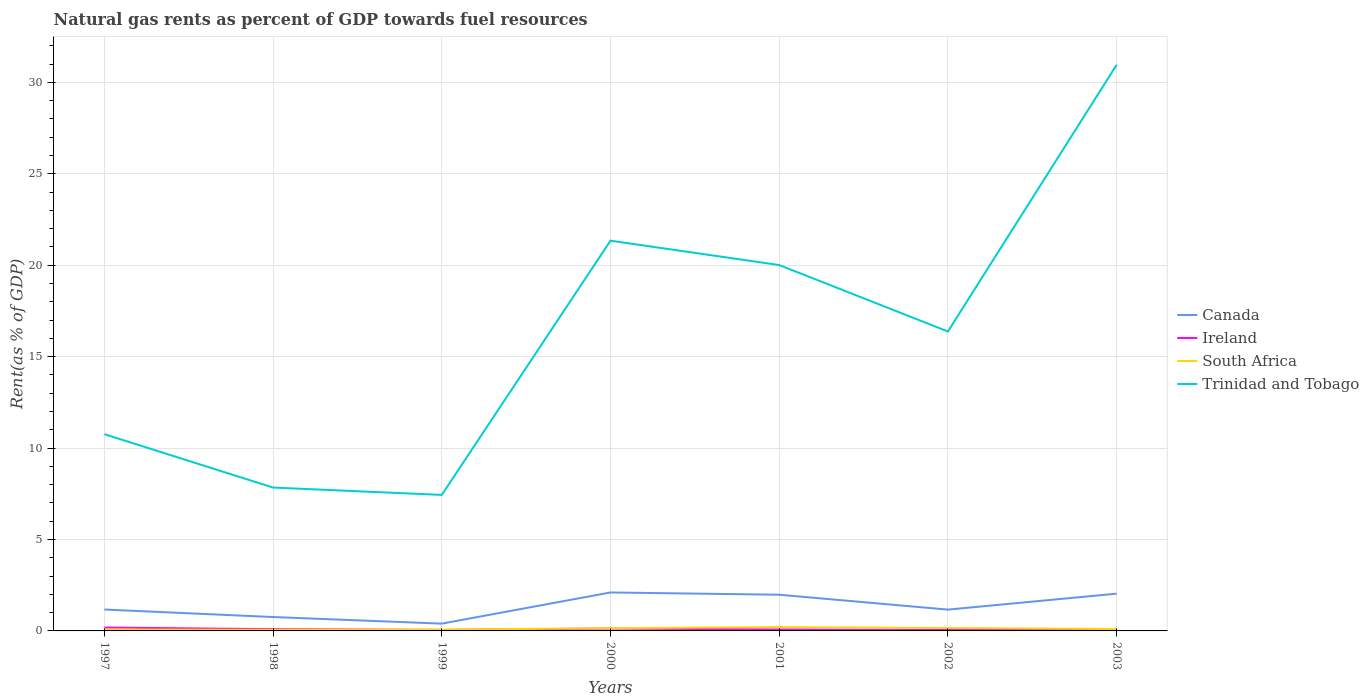Across all years, what is the maximum matural gas rent in Canada?
Offer a terse response. 0.4. In which year was the matural gas rent in Canada maximum?
Your answer should be very brief. 1999. What is the total matural gas rent in Trinidad and Tobago in the graph?
Ensure brevity in your answer.  -12.57. What is the difference between the highest and the second highest matural gas rent in Trinidad and Tobago?
Your answer should be very brief. 23.52. Is the matural gas rent in South Africa strictly greater than the matural gas rent in Ireland over the years?
Provide a succinct answer. No. How many years are there in the graph?
Provide a succinct answer. 7. Does the graph contain grids?
Offer a very short reply. Yes. How are the legend labels stacked?
Offer a terse response. Vertical. What is the title of the graph?
Your answer should be compact. Natural gas rents as percent of GDP towards fuel resources. Does "Kenya" appear as one of the legend labels in the graph?
Give a very brief answer. No. What is the label or title of the Y-axis?
Keep it short and to the point. Rent(as % of GDP). What is the Rent(as % of GDP) of Canada in 1997?
Your answer should be very brief. 1.17. What is the Rent(as % of GDP) in Ireland in 1997?
Provide a succinct answer. 0.18. What is the Rent(as % of GDP) of South Africa in 1997?
Provide a short and direct response. 0.08. What is the Rent(as % of GDP) in Trinidad and Tobago in 1997?
Keep it short and to the point. 10.76. What is the Rent(as % of GDP) in Canada in 1998?
Give a very brief answer. 0.76. What is the Rent(as % of GDP) in Ireland in 1998?
Provide a succinct answer. 0.1. What is the Rent(as % of GDP) of South Africa in 1998?
Give a very brief answer. 0.06. What is the Rent(as % of GDP) of Trinidad and Tobago in 1998?
Offer a very short reply. 7.84. What is the Rent(as % of GDP) of Canada in 1999?
Keep it short and to the point. 0.4. What is the Rent(as % of GDP) in Ireland in 1999?
Ensure brevity in your answer.  0.06. What is the Rent(as % of GDP) of South Africa in 1999?
Provide a succinct answer. 0.07. What is the Rent(as % of GDP) in Trinidad and Tobago in 1999?
Your answer should be very brief. 7.44. What is the Rent(as % of GDP) in Canada in 2000?
Provide a short and direct response. 2.1. What is the Rent(as % of GDP) of Ireland in 2000?
Your answer should be compact. 0.13. What is the Rent(as % of GDP) in South Africa in 2000?
Offer a terse response. 0.15. What is the Rent(as % of GDP) of Trinidad and Tobago in 2000?
Give a very brief answer. 21.34. What is the Rent(as % of GDP) of Canada in 2001?
Offer a terse response. 1.98. What is the Rent(as % of GDP) in Ireland in 2001?
Give a very brief answer. 0.08. What is the Rent(as % of GDP) in South Africa in 2001?
Keep it short and to the point. 0.21. What is the Rent(as % of GDP) in Trinidad and Tobago in 2001?
Make the answer very short. 20.01. What is the Rent(as % of GDP) in Canada in 2002?
Give a very brief answer. 1.17. What is the Rent(as % of GDP) of Ireland in 2002?
Your answer should be very brief. 0.05. What is the Rent(as % of GDP) in South Africa in 2002?
Keep it short and to the point. 0.16. What is the Rent(as % of GDP) of Trinidad and Tobago in 2002?
Your answer should be very brief. 16.37. What is the Rent(as % of GDP) of Canada in 2003?
Make the answer very short. 2.04. What is the Rent(as % of GDP) of Ireland in 2003?
Offer a very short reply. 0.05. What is the Rent(as % of GDP) of South Africa in 2003?
Your response must be concise. 0.1. What is the Rent(as % of GDP) in Trinidad and Tobago in 2003?
Give a very brief answer. 30.96. Across all years, what is the maximum Rent(as % of GDP) in Canada?
Give a very brief answer. 2.1. Across all years, what is the maximum Rent(as % of GDP) of Ireland?
Your response must be concise. 0.18. Across all years, what is the maximum Rent(as % of GDP) of South Africa?
Offer a very short reply. 0.21. Across all years, what is the maximum Rent(as % of GDP) of Trinidad and Tobago?
Give a very brief answer. 30.96. Across all years, what is the minimum Rent(as % of GDP) of Canada?
Make the answer very short. 0.4. Across all years, what is the minimum Rent(as % of GDP) in Ireland?
Provide a short and direct response. 0.05. Across all years, what is the minimum Rent(as % of GDP) in South Africa?
Keep it short and to the point. 0.06. Across all years, what is the minimum Rent(as % of GDP) of Trinidad and Tobago?
Provide a short and direct response. 7.44. What is the total Rent(as % of GDP) of Canada in the graph?
Your answer should be compact. 9.61. What is the total Rent(as % of GDP) of Ireland in the graph?
Give a very brief answer. 0.65. What is the total Rent(as % of GDP) in South Africa in the graph?
Offer a terse response. 0.83. What is the total Rent(as % of GDP) in Trinidad and Tobago in the graph?
Provide a succinct answer. 114.71. What is the difference between the Rent(as % of GDP) in Canada in 1997 and that in 1998?
Your answer should be very brief. 0.41. What is the difference between the Rent(as % of GDP) in Ireland in 1997 and that in 1998?
Make the answer very short. 0.09. What is the difference between the Rent(as % of GDP) in South Africa in 1997 and that in 1998?
Provide a short and direct response. 0.02. What is the difference between the Rent(as % of GDP) of Trinidad and Tobago in 1997 and that in 1998?
Ensure brevity in your answer.  2.92. What is the difference between the Rent(as % of GDP) in Canada in 1997 and that in 1999?
Make the answer very short. 0.77. What is the difference between the Rent(as % of GDP) in Ireland in 1997 and that in 1999?
Provide a short and direct response. 0.13. What is the difference between the Rent(as % of GDP) in South Africa in 1997 and that in 1999?
Provide a succinct answer. 0.01. What is the difference between the Rent(as % of GDP) of Trinidad and Tobago in 1997 and that in 1999?
Ensure brevity in your answer.  3.32. What is the difference between the Rent(as % of GDP) of Canada in 1997 and that in 2000?
Provide a succinct answer. -0.93. What is the difference between the Rent(as % of GDP) in Ireland in 1997 and that in 2000?
Make the answer very short. 0.05. What is the difference between the Rent(as % of GDP) of South Africa in 1997 and that in 2000?
Ensure brevity in your answer.  -0.07. What is the difference between the Rent(as % of GDP) in Trinidad and Tobago in 1997 and that in 2000?
Your answer should be compact. -10.58. What is the difference between the Rent(as % of GDP) of Canada in 1997 and that in 2001?
Keep it short and to the point. -0.81. What is the difference between the Rent(as % of GDP) of Ireland in 1997 and that in 2001?
Your answer should be very brief. 0.11. What is the difference between the Rent(as % of GDP) in South Africa in 1997 and that in 2001?
Keep it short and to the point. -0.13. What is the difference between the Rent(as % of GDP) of Trinidad and Tobago in 1997 and that in 2001?
Ensure brevity in your answer.  -9.25. What is the difference between the Rent(as % of GDP) of Canada in 1997 and that in 2002?
Your answer should be compact. 0. What is the difference between the Rent(as % of GDP) in Ireland in 1997 and that in 2002?
Make the answer very short. 0.14. What is the difference between the Rent(as % of GDP) in South Africa in 1997 and that in 2002?
Keep it short and to the point. -0.08. What is the difference between the Rent(as % of GDP) in Trinidad and Tobago in 1997 and that in 2002?
Keep it short and to the point. -5.61. What is the difference between the Rent(as % of GDP) of Canada in 1997 and that in 2003?
Keep it short and to the point. -0.87. What is the difference between the Rent(as % of GDP) in Ireland in 1997 and that in 2003?
Keep it short and to the point. 0.13. What is the difference between the Rent(as % of GDP) in South Africa in 1997 and that in 2003?
Provide a succinct answer. -0.02. What is the difference between the Rent(as % of GDP) of Trinidad and Tobago in 1997 and that in 2003?
Your answer should be compact. -20.2. What is the difference between the Rent(as % of GDP) in Canada in 1998 and that in 1999?
Provide a short and direct response. 0.36. What is the difference between the Rent(as % of GDP) in Ireland in 1998 and that in 1999?
Give a very brief answer. 0.04. What is the difference between the Rent(as % of GDP) in South Africa in 1998 and that in 1999?
Provide a succinct answer. -0.01. What is the difference between the Rent(as % of GDP) in Trinidad and Tobago in 1998 and that in 1999?
Your answer should be very brief. 0.4. What is the difference between the Rent(as % of GDP) in Canada in 1998 and that in 2000?
Offer a terse response. -1.34. What is the difference between the Rent(as % of GDP) in Ireland in 1998 and that in 2000?
Give a very brief answer. -0.04. What is the difference between the Rent(as % of GDP) of South Africa in 1998 and that in 2000?
Offer a very short reply. -0.09. What is the difference between the Rent(as % of GDP) of Trinidad and Tobago in 1998 and that in 2000?
Keep it short and to the point. -13.5. What is the difference between the Rent(as % of GDP) in Canada in 1998 and that in 2001?
Provide a short and direct response. -1.22. What is the difference between the Rent(as % of GDP) of Ireland in 1998 and that in 2001?
Offer a terse response. 0.02. What is the difference between the Rent(as % of GDP) in South Africa in 1998 and that in 2001?
Provide a succinct answer. -0.15. What is the difference between the Rent(as % of GDP) in Trinidad and Tobago in 1998 and that in 2001?
Keep it short and to the point. -12.17. What is the difference between the Rent(as % of GDP) in Canada in 1998 and that in 2002?
Your response must be concise. -0.41. What is the difference between the Rent(as % of GDP) in Ireland in 1998 and that in 2002?
Your response must be concise. 0.05. What is the difference between the Rent(as % of GDP) in South Africa in 1998 and that in 2002?
Provide a short and direct response. -0.1. What is the difference between the Rent(as % of GDP) in Trinidad and Tobago in 1998 and that in 2002?
Provide a succinct answer. -8.53. What is the difference between the Rent(as % of GDP) of Canada in 1998 and that in 2003?
Make the answer very short. -1.28. What is the difference between the Rent(as % of GDP) in Ireland in 1998 and that in 2003?
Provide a succinct answer. 0.04. What is the difference between the Rent(as % of GDP) of South Africa in 1998 and that in 2003?
Make the answer very short. -0.04. What is the difference between the Rent(as % of GDP) in Trinidad and Tobago in 1998 and that in 2003?
Offer a terse response. -23.12. What is the difference between the Rent(as % of GDP) of Canada in 1999 and that in 2000?
Offer a terse response. -1.7. What is the difference between the Rent(as % of GDP) in Ireland in 1999 and that in 2000?
Your answer should be compact. -0.07. What is the difference between the Rent(as % of GDP) in South Africa in 1999 and that in 2000?
Give a very brief answer. -0.08. What is the difference between the Rent(as % of GDP) in Trinidad and Tobago in 1999 and that in 2000?
Offer a very short reply. -13.9. What is the difference between the Rent(as % of GDP) in Canada in 1999 and that in 2001?
Your answer should be very brief. -1.58. What is the difference between the Rent(as % of GDP) of Ireland in 1999 and that in 2001?
Your answer should be very brief. -0.02. What is the difference between the Rent(as % of GDP) of South Africa in 1999 and that in 2001?
Keep it short and to the point. -0.14. What is the difference between the Rent(as % of GDP) in Trinidad and Tobago in 1999 and that in 2001?
Your response must be concise. -12.57. What is the difference between the Rent(as % of GDP) of Canada in 1999 and that in 2002?
Keep it short and to the point. -0.77. What is the difference between the Rent(as % of GDP) in Ireland in 1999 and that in 2002?
Make the answer very short. 0.01. What is the difference between the Rent(as % of GDP) in South Africa in 1999 and that in 2002?
Ensure brevity in your answer.  -0.09. What is the difference between the Rent(as % of GDP) of Trinidad and Tobago in 1999 and that in 2002?
Make the answer very short. -8.94. What is the difference between the Rent(as % of GDP) of Canada in 1999 and that in 2003?
Offer a terse response. -1.64. What is the difference between the Rent(as % of GDP) in Ireland in 1999 and that in 2003?
Give a very brief answer. 0. What is the difference between the Rent(as % of GDP) in South Africa in 1999 and that in 2003?
Your answer should be compact. -0.04. What is the difference between the Rent(as % of GDP) in Trinidad and Tobago in 1999 and that in 2003?
Provide a succinct answer. -23.52. What is the difference between the Rent(as % of GDP) in Canada in 2000 and that in 2001?
Provide a succinct answer. 0.12. What is the difference between the Rent(as % of GDP) of Ireland in 2000 and that in 2001?
Give a very brief answer. 0.05. What is the difference between the Rent(as % of GDP) in South Africa in 2000 and that in 2001?
Ensure brevity in your answer.  -0.06. What is the difference between the Rent(as % of GDP) of Trinidad and Tobago in 2000 and that in 2001?
Make the answer very short. 1.33. What is the difference between the Rent(as % of GDP) in Canada in 2000 and that in 2002?
Make the answer very short. 0.94. What is the difference between the Rent(as % of GDP) in Ireland in 2000 and that in 2002?
Your response must be concise. 0.08. What is the difference between the Rent(as % of GDP) of South Africa in 2000 and that in 2002?
Ensure brevity in your answer.  -0.01. What is the difference between the Rent(as % of GDP) of Trinidad and Tobago in 2000 and that in 2002?
Offer a very short reply. 4.96. What is the difference between the Rent(as % of GDP) of Canada in 2000 and that in 2003?
Make the answer very short. 0.07. What is the difference between the Rent(as % of GDP) in Ireland in 2000 and that in 2003?
Make the answer very short. 0.08. What is the difference between the Rent(as % of GDP) of South Africa in 2000 and that in 2003?
Offer a very short reply. 0.05. What is the difference between the Rent(as % of GDP) in Trinidad and Tobago in 2000 and that in 2003?
Offer a very short reply. -9.62. What is the difference between the Rent(as % of GDP) of Canada in 2001 and that in 2002?
Make the answer very short. 0.81. What is the difference between the Rent(as % of GDP) of Ireland in 2001 and that in 2002?
Ensure brevity in your answer.  0.03. What is the difference between the Rent(as % of GDP) in South Africa in 2001 and that in 2002?
Offer a terse response. 0.05. What is the difference between the Rent(as % of GDP) of Trinidad and Tobago in 2001 and that in 2002?
Provide a succinct answer. 3.63. What is the difference between the Rent(as % of GDP) in Canada in 2001 and that in 2003?
Your response must be concise. -0.06. What is the difference between the Rent(as % of GDP) in Ireland in 2001 and that in 2003?
Provide a succinct answer. 0.03. What is the difference between the Rent(as % of GDP) of South Africa in 2001 and that in 2003?
Offer a terse response. 0.11. What is the difference between the Rent(as % of GDP) of Trinidad and Tobago in 2001 and that in 2003?
Make the answer very short. -10.95. What is the difference between the Rent(as % of GDP) in Canada in 2002 and that in 2003?
Provide a short and direct response. -0.87. What is the difference between the Rent(as % of GDP) in Ireland in 2002 and that in 2003?
Your response must be concise. -0. What is the difference between the Rent(as % of GDP) of South Africa in 2002 and that in 2003?
Your answer should be very brief. 0.06. What is the difference between the Rent(as % of GDP) of Trinidad and Tobago in 2002 and that in 2003?
Give a very brief answer. -14.58. What is the difference between the Rent(as % of GDP) of Canada in 1997 and the Rent(as % of GDP) of Ireland in 1998?
Your response must be concise. 1.07. What is the difference between the Rent(as % of GDP) in Canada in 1997 and the Rent(as % of GDP) in South Africa in 1998?
Your response must be concise. 1.11. What is the difference between the Rent(as % of GDP) in Canada in 1997 and the Rent(as % of GDP) in Trinidad and Tobago in 1998?
Ensure brevity in your answer.  -6.67. What is the difference between the Rent(as % of GDP) in Ireland in 1997 and the Rent(as % of GDP) in South Africa in 1998?
Your response must be concise. 0.13. What is the difference between the Rent(as % of GDP) of Ireland in 1997 and the Rent(as % of GDP) of Trinidad and Tobago in 1998?
Your answer should be very brief. -7.66. What is the difference between the Rent(as % of GDP) in South Africa in 1997 and the Rent(as % of GDP) in Trinidad and Tobago in 1998?
Offer a very short reply. -7.76. What is the difference between the Rent(as % of GDP) of Canada in 1997 and the Rent(as % of GDP) of Ireland in 1999?
Give a very brief answer. 1.11. What is the difference between the Rent(as % of GDP) of Canada in 1997 and the Rent(as % of GDP) of South Africa in 1999?
Your response must be concise. 1.1. What is the difference between the Rent(as % of GDP) in Canada in 1997 and the Rent(as % of GDP) in Trinidad and Tobago in 1999?
Make the answer very short. -6.27. What is the difference between the Rent(as % of GDP) in Ireland in 1997 and the Rent(as % of GDP) in South Africa in 1999?
Provide a succinct answer. 0.12. What is the difference between the Rent(as % of GDP) of Ireland in 1997 and the Rent(as % of GDP) of Trinidad and Tobago in 1999?
Provide a short and direct response. -7.25. What is the difference between the Rent(as % of GDP) of South Africa in 1997 and the Rent(as % of GDP) of Trinidad and Tobago in 1999?
Your response must be concise. -7.36. What is the difference between the Rent(as % of GDP) of Canada in 1997 and the Rent(as % of GDP) of Ireland in 2000?
Your answer should be very brief. 1.04. What is the difference between the Rent(as % of GDP) of Canada in 1997 and the Rent(as % of GDP) of South Africa in 2000?
Ensure brevity in your answer.  1.02. What is the difference between the Rent(as % of GDP) in Canada in 1997 and the Rent(as % of GDP) in Trinidad and Tobago in 2000?
Ensure brevity in your answer.  -20.17. What is the difference between the Rent(as % of GDP) in Ireland in 1997 and the Rent(as % of GDP) in South Africa in 2000?
Provide a short and direct response. 0.03. What is the difference between the Rent(as % of GDP) in Ireland in 1997 and the Rent(as % of GDP) in Trinidad and Tobago in 2000?
Give a very brief answer. -21.15. What is the difference between the Rent(as % of GDP) of South Africa in 1997 and the Rent(as % of GDP) of Trinidad and Tobago in 2000?
Provide a short and direct response. -21.26. What is the difference between the Rent(as % of GDP) in Canada in 1997 and the Rent(as % of GDP) in Ireland in 2001?
Offer a terse response. 1.09. What is the difference between the Rent(as % of GDP) in Canada in 1997 and the Rent(as % of GDP) in South Africa in 2001?
Your answer should be compact. 0.96. What is the difference between the Rent(as % of GDP) in Canada in 1997 and the Rent(as % of GDP) in Trinidad and Tobago in 2001?
Your answer should be very brief. -18.84. What is the difference between the Rent(as % of GDP) of Ireland in 1997 and the Rent(as % of GDP) of South Africa in 2001?
Ensure brevity in your answer.  -0.02. What is the difference between the Rent(as % of GDP) of Ireland in 1997 and the Rent(as % of GDP) of Trinidad and Tobago in 2001?
Your answer should be compact. -19.82. What is the difference between the Rent(as % of GDP) in South Africa in 1997 and the Rent(as % of GDP) in Trinidad and Tobago in 2001?
Your answer should be very brief. -19.93. What is the difference between the Rent(as % of GDP) of Canada in 1997 and the Rent(as % of GDP) of Ireland in 2002?
Offer a terse response. 1.12. What is the difference between the Rent(as % of GDP) in Canada in 1997 and the Rent(as % of GDP) in South Africa in 2002?
Offer a very short reply. 1.01. What is the difference between the Rent(as % of GDP) in Canada in 1997 and the Rent(as % of GDP) in Trinidad and Tobago in 2002?
Ensure brevity in your answer.  -15.2. What is the difference between the Rent(as % of GDP) of Ireland in 1997 and the Rent(as % of GDP) of South Africa in 2002?
Ensure brevity in your answer.  0.02. What is the difference between the Rent(as % of GDP) of Ireland in 1997 and the Rent(as % of GDP) of Trinidad and Tobago in 2002?
Provide a succinct answer. -16.19. What is the difference between the Rent(as % of GDP) in South Africa in 1997 and the Rent(as % of GDP) in Trinidad and Tobago in 2002?
Your response must be concise. -16.29. What is the difference between the Rent(as % of GDP) of Canada in 1997 and the Rent(as % of GDP) of Ireland in 2003?
Provide a short and direct response. 1.12. What is the difference between the Rent(as % of GDP) of Canada in 1997 and the Rent(as % of GDP) of South Africa in 2003?
Offer a very short reply. 1.07. What is the difference between the Rent(as % of GDP) in Canada in 1997 and the Rent(as % of GDP) in Trinidad and Tobago in 2003?
Your answer should be very brief. -29.79. What is the difference between the Rent(as % of GDP) of Ireland in 1997 and the Rent(as % of GDP) of South Africa in 2003?
Offer a terse response. 0.08. What is the difference between the Rent(as % of GDP) of Ireland in 1997 and the Rent(as % of GDP) of Trinidad and Tobago in 2003?
Ensure brevity in your answer.  -30.77. What is the difference between the Rent(as % of GDP) in South Africa in 1997 and the Rent(as % of GDP) in Trinidad and Tobago in 2003?
Give a very brief answer. -30.88. What is the difference between the Rent(as % of GDP) of Canada in 1998 and the Rent(as % of GDP) of Ireland in 1999?
Provide a short and direct response. 0.7. What is the difference between the Rent(as % of GDP) in Canada in 1998 and the Rent(as % of GDP) in South Africa in 1999?
Provide a short and direct response. 0.69. What is the difference between the Rent(as % of GDP) of Canada in 1998 and the Rent(as % of GDP) of Trinidad and Tobago in 1999?
Keep it short and to the point. -6.68. What is the difference between the Rent(as % of GDP) of Ireland in 1998 and the Rent(as % of GDP) of South Africa in 1999?
Offer a very short reply. 0.03. What is the difference between the Rent(as % of GDP) of Ireland in 1998 and the Rent(as % of GDP) of Trinidad and Tobago in 1999?
Offer a terse response. -7.34. What is the difference between the Rent(as % of GDP) in South Africa in 1998 and the Rent(as % of GDP) in Trinidad and Tobago in 1999?
Make the answer very short. -7.38. What is the difference between the Rent(as % of GDP) in Canada in 1998 and the Rent(as % of GDP) in Ireland in 2000?
Your response must be concise. 0.63. What is the difference between the Rent(as % of GDP) in Canada in 1998 and the Rent(as % of GDP) in South Africa in 2000?
Make the answer very short. 0.61. What is the difference between the Rent(as % of GDP) of Canada in 1998 and the Rent(as % of GDP) of Trinidad and Tobago in 2000?
Keep it short and to the point. -20.58. What is the difference between the Rent(as % of GDP) in Ireland in 1998 and the Rent(as % of GDP) in South Africa in 2000?
Your response must be concise. -0.05. What is the difference between the Rent(as % of GDP) in Ireland in 1998 and the Rent(as % of GDP) in Trinidad and Tobago in 2000?
Offer a terse response. -21.24. What is the difference between the Rent(as % of GDP) in South Africa in 1998 and the Rent(as % of GDP) in Trinidad and Tobago in 2000?
Ensure brevity in your answer.  -21.28. What is the difference between the Rent(as % of GDP) of Canada in 1998 and the Rent(as % of GDP) of Ireland in 2001?
Your answer should be compact. 0.68. What is the difference between the Rent(as % of GDP) in Canada in 1998 and the Rent(as % of GDP) in South Africa in 2001?
Offer a terse response. 0.55. What is the difference between the Rent(as % of GDP) in Canada in 1998 and the Rent(as % of GDP) in Trinidad and Tobago in 2001?
Give a very brief answer. -19.25. What is the difference between the Rent(as % of GDP) of Ireland in 1998 and the Rent(as % of GDP) of South Africa in 2001?
Your answer should be very brief. -0.11. What is the difference between the Rent(as % of GDP) of Ireland in 1998 and the Rent(as % of GDP) of Trinidad and Tobago in 2001?
Your answer should be compact. -19.91. What is the difference between the Rent(as % of GDP) in South Africa in 1998 and the Rent(as % of GDP) in Trinidad and Tobago in 2001?
Provide a short and direct response. -19.95. What is the difference between the Rent(as % of GDP) in Canada in 1998 and the Rent(as % of GDP) in Ireland in 2002?
Give a very brief answer. 0.71. What is the difference between the Rent(as % of GDP) of Canada in 1998 and the Rent(as % of GDP) of South Africa in 2002?
Give a very brief answer. 0.6. What is the difference between the Rent(as % of GDP) of Canada in 1998 and the Rent(as % of GDP) of Trinidad and Tobago in 2002?
Your response must be concise. -15.61. What is the difference between the Rent(as % of GDP) in Ireland in 1998 and the Rent(as % of GDP) in South Africa in 2002?
Provide a short and direct response. -0.07. What is the difference between the Rent(as % of GDP) in Ireland in 1998 and the Rent(as % of GDP) in Trinidad and Tobago in 2002?
Provide a short and direct response. -16.28. What is the difference between the Rent(as % of GDP) of South Africa in 1998 and the Rent(as % of GDP) of Trinidad and Tobago in 2002?
Provide a succinct answer. -16.32. What is the difference between the Rent(as % of GDP) of Canada in 1998 and the Rent(as % of GDP) of Ireland in 2003?
Your response must be concise. 0.71. What is the difference between the Rent(as % of GDP) of Canada in 1998 and the Rent(as % of GDP) of South Africa in 2003?
Your answer should be very brief. 0.66. What is the difference between the Rent(as % of GDP) in Canada in 1998 and the Rent(as % of GDP) in Trinidad and Tobago in 2003?
Offer a terse response. -30.2. What is the difference between the Rent(as % of GDP) in Ireland in 1998 and the Rent(as % of GDP) in South Africa in 2003?
Ensure brevity in your answer.  -0.01. What is the difference between the Rent(as % of GDP) in Ireland in 1998 and the Rent(as % of GDP) in Trinidad and Tobago in 2003?
Ensure brevity in your answer.  -30.86. What is the difference between the Rent(as % of GDP) in South Africa in 1998 and the Rent(as % of GDP) in Trinidad and Tobago in 2003?
Make the answer very short. -30.9. What is the difference between the Rent(as % of GDP) in Canada in 1999 and the Rent(as % of GDP) in Ireland in 2000?
Offer a very short reply. 0.27. What is the difference between the Rent(as % of GDP) of Canada in 1999 and the Rent(as % of GDP) of South Africa in 2000?
Your answer should be compact. 0.25. What is the difference between the Rent(as % of GDP) in Canada in 1999 and the Rent(as % of GDP) in Trinidad and Tobago in 2000?
Offer a terse response. -20.94. What is the difference between the Rent(as % of GDP) in Ireland in 1999 and the Rent(as % of GDP) in South Africa in 2000?
Offer a terse response. -0.09. What is the difference between the Rent(as % of GDP) of Ireland in 1999 and the Rent(as % of GDP) of Trinidad and Tobago in 2000?
Ensure brevity in your answer.  -21.28. What is the difference between the Rent(as % of GDP) in South Africa in 1999 and the Rent(as % of GDP) in Trinidad and Tobago in 2000?
Offer a terse response. -21.27. What is the difference between the Rent(as % of GDP) in Canada in 1999 and the Rent(as % of GDP) in Ireland in 2001?
Your answer should be compact. 0.32. What is the difference between the Rent(as % of GDP) of Canada in 1999 and the Rent(as % of GDP) of South Africa in 2001?
Give a very brief answer. 0.19. What is the difference between the Rent(as % of GDP) in Canada in 1999 and the Rent(as % of GDP) in Trinidad and Tobago in 2001?
Make the answer very short. -19.61. What is the difference between the Rent(as % of GDP) of Ireland in 1999 and the Rent(as % of GDP) of South Africa in 2001?
Offer a very short reply. -0.15. What is the difference between the Rent(as % of GDP) of Ireland in 1999 and the Rent(as % of GDP) of Trinidad and Tobago in 2001?
Keep it short and to the point. -19.95. What is the difference between the Rent(as % of GDP) in South Africa in 1999 and the Rent(as % of GDP) in Trinidad and Tobago in 2001?
Offer a very short reply. -19.94. What is the difference between the Rent(as % of GDP) of Canada in 1999 and the Rent(as % of GDP) of Ireland in 2002?
Provide a succinct answer. 0.35. What is the difference between the Rent(as % of GDP) of Canada in 1999 and the Rent(as % of GDP) of South Africa in 2002?
Make the answer very short. 0.24. What is the difference between the Rent(as % of GDP) of Canada in 1999 and the Rent(as % of GDP) of Trinidad and Tobago in 2002?
Keep it short and to the point. -15.98. What is the difference between the Rent(as % of GDP) of Ireland in 1999 and the Rent(as % of GDP) of South Africa in 2002?
Give a very brief answer. -0.1. What is the difference between the Rent(as % of GDP) in Ireland in 1999 and the Rent(as % of GDP) in Trinidad and Tobago in 2002?
Make the answer very short. -16.32. What is the difference between the Rent(as % of GDP) of South Africa in 1999 and the Rent(as % of GDP) of Trinidad and Tobago in 2002?
Your answer should be compact. -16.31. What is the difference between the Rent(as % of GDP) of Canada in 1999 and the Rent(as % of GDP) of Ireland in 2003?
Provide a succinct answer. 0.35. What is the difference between the Rent(as % of GDP) of Canada in 1999 and the Rent(as % of GDP) of South Africa in 2003?
Keep it short and to the point. 0.3. What is the difference between the Rent(as % of GDP) of Canada in 1999 and the Rent(as % of GDP) of Trinidad and Tobago in 2003?
Give a very brief answer. -30.56. What is the difference between the Rent(as % of GDP) in Ireland in 1999 and the Rent(as % of GDP) in South Africa in 2003?
Keep it short and to the point. -0.05. What is the difference between the Rent(as % of GDP) in Ireland in 1999 and the Rent(as % of GDP) in Trinidad and Tobago in 2003?
Keep it short and to the point. -30.9. What is the difference between the Rent(as % of GDP) in South Africa in 1999 and the Rent(as % of GDP) in Trinidad and Tobago in 2003?
Your answer should be compact. -30.89. What is the difference between the Rent(as % of GDP) in Canada in 2000 and the Rent(as % of GDP) in Ireland in 2001?
Give a very brief answer. 2.02. What is the difference between the Rent(as % of GDP) of Canada in 2000 and the Rent(as % of GDP) of South Africa in 2001?
Give a very brief answer. 1.89. What is the difference between the Rent(as % of GDP) in Canada in 2000 and the Rent(as % of GDP) in Trinidad and Tobago in 2001?
Provide a short and direct response. -17.9. What is the difference between the Rent(as % of GDP) in Ireland in 2000 and the Rent(as % of GDP) in South Africa in 2001?
Your answer should be very brief. -0.08. What is the difference between the Rent(as % of GDP) of Ireland in 2000 and the Rent(as % of GDP) of Trinidad and Tobago in 2001?
Your response must be concise. -19.88. What is the difference between the Rent(as % of GDP) in South Africa in 2000 and the Rent(as % of GDP) in Trinidad and Tobago in 2001?
Ensure brevity in your answer.  -19.86. What is the difference between the Rent(as % of GDP) of Canada in 2000 and the Rent(as % of GDP) of Ireland in 2002?
Your answer should be compact. 2.05. What is the difference between the Rent(as % of GDP) of Canada in 2000 and the Rent(as % of GDP) of South Africa in 2002?
Provide a short and direct response. 1.94. What is the difference between the Rent(as % of GDP) in Canada in 2000 and the Rent(as % of GDP) in Trinidad and Tobago in 2002?
Ensure brevity in your answer.  -14.27. What is the difference between the Rent(as % of GDP) of Ireland in 2000 and the Rent(as % of GDP) of South Africa in 2002?
Ensure brevity in your answer.  -0.03. What is the difference between the Rent(as % of GDP) in Ireland in 2000 and the Rent(as % of GDP) in Trinidad and Tobago in 2002?
Offer a terse response. -16.24. What is the difference between the Rent(as % of GDP) in South Africa in 2000 and the Rent(as % of GDP) in Trinidad and Tobago in 2002?
Offer a very short reply. -16.22. What is the difference between the Rent(as % of GDP) of Canada in 2000 and the Rent(as % of GDP) of Ireland in 2003?
Your response must be concise. 2.05. What is the difference between the Rent(as % of GDP) of Canada in 2000 and the Rent(as % of GDP) of South Africa in 2003?
Keep it short and to the point. 2. What is the difference between the Rent(as % of GDP) in Canada in 2000 and the Rent(as % of GDP) in Trinidad and Tobago in 2003?
Provide a succinct answer. -28.85. What is the difference between the Rent(as % of GDP) in Ireland in 2000 and the Rent(as % of GDP) in South Africa in 2003?
Your answer should be compact. 0.03. What is the difference between the Rent(as % of GDP) in Ireland in 2000 and the Rent(as % of GDP) in Trinidad and Tobago in 2003?
Provide a short and direct response. -30.82. What is the difference between the Rent(as % of GDP) of South Africa in 2000 and the Rent(as % of GDP) of Trinidad and Tobago in 2003?
Your answer should be compact. -30.81. What is the difference between the Rent(as % of GDP) of Canada in 2001 and the Rent(as % of GDP) of Ireland in 2002?
Keep it short and to the point. 1.93. What is the difference between the Rent(as % of GDP) of Canada in 2001 and the Rent(as % of GDP) of South Africa in 2002?
Offer a very short reply. 1.82. What is the difference between the Rent(as % of GDP) in Canada in 2001 and the Rent(as % of GDP) in Trinidad and Tobago in 2002?
Your response must be concise. -14.39. What is the difference between the Rent(as % of GDP) in Ireland in 2001 and the Rent(as % of GDP) in South Africa in 2002?
Make the answer very short. -0.08. What is the difference between the Rent(as % of GDP) of Ireland in 2001 and the Rent(as % of GDP) of Trinidad and Tobago in 2002?
Provide a short and direct response. -16.3. What is the difference between the Rent(as % of GDP) in South Africa in 2001 and the Rent(as % of GDP) in Trinidad and Tobago in 2002?
Make the answer very short. -16.16. What is the difference between the Rent(as % of GDP) of Canada in 2001 and the Rent(as % of GDP) of Ireland in 2003?
Keep it short and to the point. 1.93. What is the difference between the Rent(as % of GDP) in Canada in 2001 and the Rent(as % of GDP) in South Africa in 2003?
Keep it short and to the point. 1.88. What is the difference between the Rent(as % of GDP) of Canada in 2001 and the Rent(as % of GDP) of Trinidad and Tobago in 2003?
Your answer should be compact. -28.98. What is the difference between the Rent(as % of GDP) in Ireland in 2001 and the Rent(as % of GDP) in South Africa in 2003?
Keep it short and to the point. -0.03. What is the difference between the Rent(as % of GDP) in Ireland in 2001 and the Rent(as % of GDP) in Trinidad and Tobago in 2003?
Ensure brevity in your answer.  -30.88. What is the difference between the Rent(as % of GDP) of South Africa in 2001 and the Rent(as % of GDP) of Trinidad and Tobago in 2003?
Your response must be concise. -30.75. What is the difference between the Rent(as % of GDP) in Canada in 2002 and the Rent(as % of GDP) in Ireland in 2003?
Provide a succinct answer. 1.11. What is the difference between the Rent(as % of GDP) of Canada in 2002 and the Rent(as % of GDP) of South Africa in 2003?
Make the answer very short. 1.06. What is the difference between the Rent(as % of GDP) in Canada in 2002 and the Rent(as % of GDP) in Trinidad and Tobago in 2003?
Your answer should be compact. -29.79. What is the difference between the Rent(as % of GDP) in Ireland in 2002 and the Rent(as % of GDP) in South Africa in 2003?
Give a very brief answer. -0.05. What is the difference between the Rent(as % of GDP) of Ireland in 2002 and the Rent(as % of GDP) of Trinidad and Tobago in 2003?
Your response must be concise. -30.91. What is the difference between the Rent(as % of GDP) of South Africa in 2002 and the Rent(as % of GDP) of Trinidad and Tobago in 2003?
Offer a very short reply. -30.79. What is the average Rent(as % of GDP) of Canada per year?
Provide a succinct answer. 1.37. What is the average Rent(as % of GDP) of Ireland per year?
Your answer should be compact. 0.09. What is the average Rent(as % of GDP) in South Africa per year?
Your answer should be very brief. 0.12. What is the average Rent(as % of GDP) in Trinidad and Tobago per year?
Make the answer very short. 16.39. In the year 1997, what is the difference between the Rent(as % of GDP) of Canada and Rent(as % of GDP) of Ireland?
Give a very brief answer. 0.98. In the year 1997, what is the difference between the Rent(as % of GDP) of Canada and Rent(as % of GDP) of South Africa?
Your response must be concise. 1.09. In the year 1997, what is the difference between the Rent(as % of GDP) of Canada and Rent(as % of GDP) of Trinidad and Tobago?
Make the answer very short. -9.59. In the year 1997, what is the difference between the Rent(as % of GDP) of Ireland and Rent(as % of GDP) of South Africa?
Your answer should be compact. 0.1. In the year 1997, what is the difference between the Rent(as % of GDP) in Ireland and Rent(as % of GDP) in Trinidad and Tobago?
Give a very brief answer. -10.57. In the year 1997, what is the difference between the Rent(as % of GDP) in South Africa and Rent(as % of GDP) in Trinidad and Tobago?
Offer a very short reply. -10.68. In the year 1998, what is the difference between the Rent(as % of GDP) in Canada and Rent(as % of GDP) in Ireland?
Offer a terse response. 0.66. In the year 1998, what is the difference between the Rent(as % of GDP) of Canada and Rent(as % of GDP) of South Africa?
Make the answer very short. 0.7. In the year 1998, what is the difference between the Rent(as % of GDP) of Canada and Rent(as % of GDP) of Trinidad and Tobago?
Make the answer very short. -7.08. In the year 1998, what is the difference between the Rent(as % of GDP) in Ireland and Rent(as % of GDP) in South Africa?
Your response must be concise. 0.04. In the year 1998, what is the difference between the Rent(as % of GDP) of Ireland and Rent(as % of GDP) of Trinidad and Tobago?
Your answer should be compact. -7.74. In the year 1998, what is the difference between the Rent(as % of GDP) in South Africa and Rent(as % of GDP) in Trinidad and Tobago?
Keep it short and to the point. -7.78. In the year 1999, what is the difference between the Rent(as % of GDP) of Canada and Rent(as % of GDP) of Ireland?
Give a very brief answer. 0.34. In the year 1999, what is the difference between the Rent(as % of GDP) of Canada and Rent(as % of GDP) of South Africa?
Give a very brief answer. 0.33. In the year 1999, what is the difference between the Rent(as % of GDP) of Canada and Rent(as % of GDP) of Trinidad and Tobago?
Your answer should be very brief. -7.04. In the year 1999, what is the difference between the Rent(as % of GDP) in Ireland and Rent(as % of GDP) in South Africa?
Your answer should be very brief. -0.01. In the year 1999, what is the difference between the Rent(as % of GDP) of Ireland and Rent(as % of GDP) of Trinidad and Tobago?
Offer a very short reply. -7.38. In the year 1999, what is the difference between the Rent(as % of GDP) in South Africa and Rent(as % of GDP) in Trinidad and Tobago?
Your answer should be compact. -7.37. In the year 2000, what is the difference between the Rent(as % of GDP) of Canada and Rent(as % of GDP) of Ireland?
Keep it short and to the point. 1.97. In the year 2000, what is the difference between the Rent(as % of GDP) of Canada and Rent(as % of GDP) of South Africa?
Your response must be concise. 1.95. In the year 2000, what is the difference between the Rent(as % of GDP) in Canada and Rent(as % of GDP) in Trinidad and Tobago?
Offer a very short reply. -19.24. In the year 2000, what is the difference between the Rent(as % of GDP) of Ireland and Rent(as % of GDP) of South Africa?
Give a very brief answer. -0.02. In the year 2000, what is the difference between the Rent(as % of GDP) in Ireland and Rent(as % of GDP) in Trinidad and Tobago?
Make the answer very short. -21.21. In the year 2000, what is the difference between the Rent(as % of GDP) in South Africa and Rent(as % of GDP) in Trinidad and Tobago?
Provide a short and direct response. -21.19. In the year 2001, what is the difference between the Rent(as % of GDP) of Canada and Rent(as % of GDP) of Ireland?
Your answer should be compact. 1.9. In the year 2001, what is the difference between the Rent(as % of GDP) of Canada and Rent(as % of GDP) of South Africa?
Give a very brief answer. 1.77. In the year 2001, what is the difference between the Rent(as % of GDP) of Canada and Rent(as % of GDP) of Trinidad and Tobago?
Offer a very short reply. -18.03. In the year 2001, what is the difference between the Rent(as % of GDP) of Ireland and Rent(as % of GDP) of South Africa?
Your answer should be very brief. -0.13. In the year 2001, what is the difference between the Rent(as % of GDP) of Ireland and Rent(as % of GDP) of Trinidad and Tobago?
Your response must be concise. -19.93. In the year 2001, what is the difference between the Rent(as % of GDP) in South Africa and Rent(as % of GDP) in Trinidad and Tobago?
Make the answer very short. -19.8. In the year 2002, what is the difference between the Rent(as % of GDP) in Canada and Rent(as % of GDP) in Ireland?
Provide a succinct answer. 1.12. In the year 2002, what is the difference between the Rent(as % of GDP) of Canada and Rent(as % of GDP) of Trinidad and Tobago?
Your response must be concise. -15.21. In the year 2002, what is the difference between the Rent(as % of GDP) in Ireland and Rent(as % of GDP) in South Africa?
Give a very brief answer. -0.11. In the year 2002, what is the difference between the Rent(as % of GDP) in Ireland and Rent(as % of GDP) in Trinidad and Tobago?
Provide a succinct answer. -16.33. In the year 2002, what is the difference between the Rent(as % of GDP) in South Africa and Rent(as % of GDP) in Trinidad and Tobago?
Ensure brevity in your answer.  -16.21. In the year 2003, what is the difference between the Rent(as % of GDP) in Canada and Rent(as % of GDP) in Ireland?
Provide a succinct answer. 1.99. In the year 2003, what is the difference between the Rent(as % of GDP) in Canada and Rent(as % of GDP) in South Africa?
Give a very brief answer. 1.93. In the year 2003, what is the difference between the Rent(as % of GDP) in Canada and Rent(as % of GDP) in Trinidad and Tobago?
Your response must be concise. -28.92. In the year 2003, what is the difference between the Rent(as % of GDP) of Ireland and Rent(as % of GDP) of South Africa?
Offer a terse response. -0.05. In the year 2003, what is the difference between the Rent(as % of GDP) in Ireland and Rent(as % of GDP) in Trinidad and Tobago?
Give a very brief answer. -30.9. In the year 2003, what is the difference between the Rent(as % of GDP) of South Africa and Rent(as % of GDP) of Trinidad and Tobago?
Your answer should be compact. -30.85. What is the ratio of the Rent(as % of GDP) of Canada in 1997 to that in 1998?
Your answer should be very brief. 1.54. What is the ratio of the Rent(as % of GDP) in Ireland in 1997 to that in 1998?
Offer a very short reply. 1.94. What is the ratio of the Rent(as % of GDP) of South Africa in 1997 to that in 1998?
Your response must be concise. 1.36. What is the ratio of the Rent(as % of GDP) of Trinidad and Tobago in 1997 to that in 1998?
Provide a short and direct response. 1.37. What is the ratio of the Rent(as % of GDP) of Canada in 1997 to that in 1999?
Offer a very short reply. 2.93. What is the ratio of the Rent(as % of GDP) in Ireland in 1997 to that in 1999?
Offer a terse response. 3.26. What is the ratio of the Rent(as % of GDP) of South Africa in 1997 to that in 1999?
Offer a terse response. 1.16. What is the ratio of the Rent(as % of GDP) in Trinidad and Tobago in 1997 to that in 1999?
Your answer should be very brief. 1.45. What is the ratio of the Rent(as % of GDP) of Canada in 1997 to that in 2000?
Ensure brevity in your answer.  0.56. What is the ratio of the Rent(as % of GDP) of Ireland in 1997 to that in 2000?
Your answer should be compact. 1.41. What is the ratio of the Rent(as % of GDP) in South Africa in 1997 to that in 2000?
Your response must be concise. 0.53. What is the ratio of the Rent(as % of GDP) in Trinidad and Tobago in 1997 to that in 2000?
Provide a short and direct response. 0.5. What is the ratio of the Rent(as % of GDP) in Canada in 1997 to that in 2001?
Offer a very short reply. 0.59. What is the ratio of the Rent(as % of GDP) of Ireland in 1997 to that in 2001?
Give a very brief answer. 2.36. What is the ratio of the Rent(as % of GDP) in South Africa in 1997 to that in 2001?
Offer a terse response. 0.38. What is the ratio of the Rent(as % of GDP) in Trinidad and Tobago in 1997 to that in 2001?
Offer a terse response. 0.54. What is the ratio of the Rent(as % of GDP) in Ireland in 1997 to that in 2002?
Your response must be concise. 3.78. What is the ratio of the Rent(as % of GDP) of South Africa in 1997 to that in 2002?
Ensure brevity in your answer.  0.49. What is the ratio of the Rent(as % of GDP) of Trinidad and Tobago in 1997 to that in 2002?
Provide a succinct answer. 0.66. What is the ratio of the Rent(as % of GDP) of Canada in 1997 to that in 2003?
Offer a very short reply. 0.57. What is the ratio of the Rent(as % of GDP) in Ireland in 1997 to that in 2003?
Your response must be concise. 3.55. What is the ratio of the Rent(as % of GDP) in South Africa in 1997 to that in 2003?
Your response must be concise. 0.77. What is the ratio of the Rent(as % of GDP) in Trinidad and Tobago in 1997 to that in 2003?
Offer a terse response. 0.35. What is the ratio of the Rent(as % of GDP) of Canada in 1998 to that in 1999?
Give a very brief answer. 1.9. What is the ratio of the Rent(as % of GDP) in Ireland in 1998 to that in 1999?
Keep it short and to the point. 1.68. What is the ratio of the Rent(as % of GDP) of South Africa in 1998 to that in 1999?
Provide a short and direct response. 0.86. What is the ratio of the Rent(as % of GDP) in Trinidad and Tobago in 1998 to that in 1999?
Ensure brevity in your answer.  1.05. What is the ratio of the Rent(as % of GDP) of Canada in 1998 to that in 2000?
Your answer should be compact. 0.36. What is the ratio of the Rent(as % of GDP) in Ireland in 1998 to that in 2000?
Give a very brief answer. 0.73. What is the ratio of the Rent(as % of GDP) in South Africa in 1998 to that in 2000?
Your response must be concise. 0.39. What is the ratio of the Rent(as % of GDP) in Trinidad and Tobago in 1998 to that in 2000?
Give a very brief answer. 0.37. What is the ratio of the Rent(as % of GDP) in Canada in 1998 to that in 2001?
Make the answer very short. 0.38. What is the ratio of the Rent(as % of GDP) in Ireland in 1998 to that in 2001?
Offer a terse response. 1.21. What is the ratio of the Rent(as % of GDP) of South Africa in 1998 to that in 2001?
Your answer should be compact. 0.28. What is the ratio of the Rent(as % of GDP) in Trinidad and Tobago in 1998 to that in 2001?
Your answer should be compact. 0.39. What is the ratio of the Rent(as % of GDP) of Canada in 1998 to that in 2002?
Provide a succinct answer. 0.65. What is the ratio of the Rent(as % of GDP) in Ireland in 1998 to that in 2002?
Keep it short and to the point. 1.95. What is the ratio of the Rent(as % of GDP) in South Africa in 1998 to that in 2002?
Your response must be concise. 0.36. What is the ratio of the Rent(as % of GDP) of Trinidad and Tobago in 1998 to that in 2002?
Provide a succinct answer. 0.48. What is the ratio of the Rent(as % of GDP) of Canada in 1998 to that in 2003?
Your answer should be compact. 0.37. What is the ratio of the Rent(as % of GDP) of Ireland in 1998 to that in 2003?
Offer a terse response. 1.83. What is the ratio of the Rent(as % of GDP) in South Africa in 1998 to that in 2003?
Provide a short and direct response. 0.57. What is the ratio of the Rent(as % of GDP) of Trinidad and Tobago in 1998 to that in 2003?
Make the answer very short. 0.25. What is the ratio of the Rent(as % of GDP) in Canada in 1999 to that in 2000?
Your answer should be compact. 0.19. What is the ratio of the Rent(as % of GDP) of Ireland in 1999 to that in 2000?
Offer a terse response. 0.43. What is the ratio of the Rent(as % of GDP) in South Africa in 1999 to that in 2000?
Your answer should be very brief. 0.46. What is the ratio of the Rent(as % of GDP) in Trinidad and Tobago in 1999 to that in 2000?
Offer a terse response. 0.35. What is the ratio of the Rent(as % of GDP) of Canada in 1999 to that in 2001?
Offer a terse response. 0.2. What is the ratio of the Rent(as % of GDP) in Ireland in 1999 to that in 2001?
Offer a terse response. 0.72. What is the ratio of the Rent(as % of GDP) of South Africa in 1999 to that in 2001?
Give a very brief answer. 0.33. What is the ratio of the Rent(as % of GDP) of Trinidad and Tobago in 1999 to that in 2001?
Give a very brief answer. 0.37. What is the ratio of the Rent(as % of GDP) of Canada in 1999 to that in 2002?
Your answer should be compact. 0.34. What is the ratio of the Rent(as % of GDP) in Ireland in 1999 to that in 2002?
Keep it short and to the point. 1.16. What is the ratio of the Rent(as % of GDP) in South Africa in 1999 to that in 2002?
Give a very brief answer. 0.42. What is the ratio of the Rent(as % of GDP) of Trinidad and Tobago in 1999 to that in 2002?
Offer a terse response. 0.45. What is the ratio of the Rent(as % of GDP) of Canada in 1999 to that in 2003?
Provide a succinct answer. 0.2. What is the ratio of the Rent(as % of GDP) in Ireland in 1999 to that in 2003?
Offer a very short reply. 1.09. What is the ratio of the Rent(as % of GDP) of South Africa in 1999 to that in 2003?
Provide a short and direct response. 0.66. What is the ratio of the Rent(as % of GDP) of Trinidad and Tobago in 1999 to that in 2003?
Give a very brief answer. 0.24. What is the ratio of the Rent(as % of GDP) in Canada in 2000 to that in 2001?
Your response must be concise. 1.06. What is the ratio of the Rent(as % of GDP) of Ireland in 2000 to that in 2001?
Provide a succinct answer. 1.67. What is the ratio of the Rent(as % of GDP) of South Africa in 2000 to that in 2001?
Offer a terse response. 0.72. What is the ratio of the Rent(as % of GDP) of Trinidad and Tobago in 2000 to that in 2001?
Provide a short and direct response. 1.07. What is the ratio of the Rent(as % of GDP) of Canada in 2000 to that in 2002?
Keep it short and to the point. 1.8. What is the ratio of the Rent(as % of GDP) of Ireland in 2000 to that in 2002?
Offer a very short reply. 2.69. What is the ratio of the Rent(as % of GDP) in South Africa in 2000 to that in 2002?
Your response must be concise. 0.93. What is the ratio of the Rent(as % of GDP) of Trinidad and Tobago in 2000 to that in 2002?
Provide a short and direct response. 1.3. What is the ratio of the Rent(as % of GDP) of Canada in 2000 to that in 2003?
Your response must be concise. 1.03. What is the ratio of the Rent(as % of GDP) in Ireland in 2000 to that in 2003?
Your answer should be very brief. 2.52. What is the ratio of the Rent(as % of GDP) of South Africa in 2000 to that in 2003?
Ensure brevity in your answer.  1.45. What is the ratio of the Rent(as % of GDP) in Trinidad and Tobago in 2000 to that in 2003?
Make the answer very short. 0.69. What is the ratio of the Rent(as % of GDP) in Canada in 2001 to that in 2002?
Your answer should be very brief. 1.7. What is the ratio of the Rent(as % of GDP) of Ireland in 2001 to that in 2002?
Give a very brief answer. 1.6. What is the ratio of the Rent(as % of GDP) in South Africa in 2001 to that in 2002?
Your answer should be very brief. 1.3. What is the ratio of the Rent(as % of GDP) of Trinidad and Tobago in 2001 to that in 2002?
Your answer should be compact. 1.22. What is the ratio of the Rent(as % of GDP) in Canada in 2001 to that in 2003?
Provide a short and direct response. 0.97. What is the ratio of the Rent(as % of GDP) in Ireland in 2001 to that in 2003?
Keep it short and to the point. 1.51. What is the ratio of the Rent(as % of GDP) of South Africa in 2001 to that in 2003?
Offer a very short reply. 2.02. What is the ratio of the Rent(as % of GDP) in Trinidad and Tobago in 2001 to that in 2003?
Provide a short and direct response. 0.65. What is the ratio of the Rent(as % of GDP) in Canada in 2002 to that in 2003?
Offer a very short reply. 0.57. What is the ratio of the Rent(as % of GDP) of Ireland in 2002 to that in 2003?
Give a very brief answer. 0.94. What is the ratio of the Rent(as % of GDP) of South Africa in 2002 to that in 2003?
Offer a terse response. 1.56. What is the ratio of the Rent(as % of GDP) in Trinidad and Tobago in 2002 to that in 2003?
Make the answer very short. 0.53. What is the difference between the highest and the second highest Rent(as % of GDP) in Canada?
Ensure brevity in your answer.  0.07. What is the difference between the highest and the second highest Rent(as % of GDP) of Ireland?
Give a very brief answer. 0.05. What is the difference between the highest and the second highest Rent(as % of GDP) in South Africa?
Your response must be concise. 0.05. What is the difference between the highest and the second highest Rent(as % of GDP) of Trinidad and Tobago?
Make the answer very short. 9.62. What is the difference between the highest and the lowest Rent(as % of GDP) of Canada?
Your response must be concise. 1.7. What is the difference between the highest and the lowest Rent(as % of GDP) in Ireland?
Your response must be concise. 0.14. What is the difference between the highest and the lowest Rent(as % of GDP) in South Africa?
Your answer should be very brief. 0.15. What is the difference between the highest and the lowest Rent(as % of GDP) in Trinidad and Tobago?
Offer a very short reply. 23.52. 